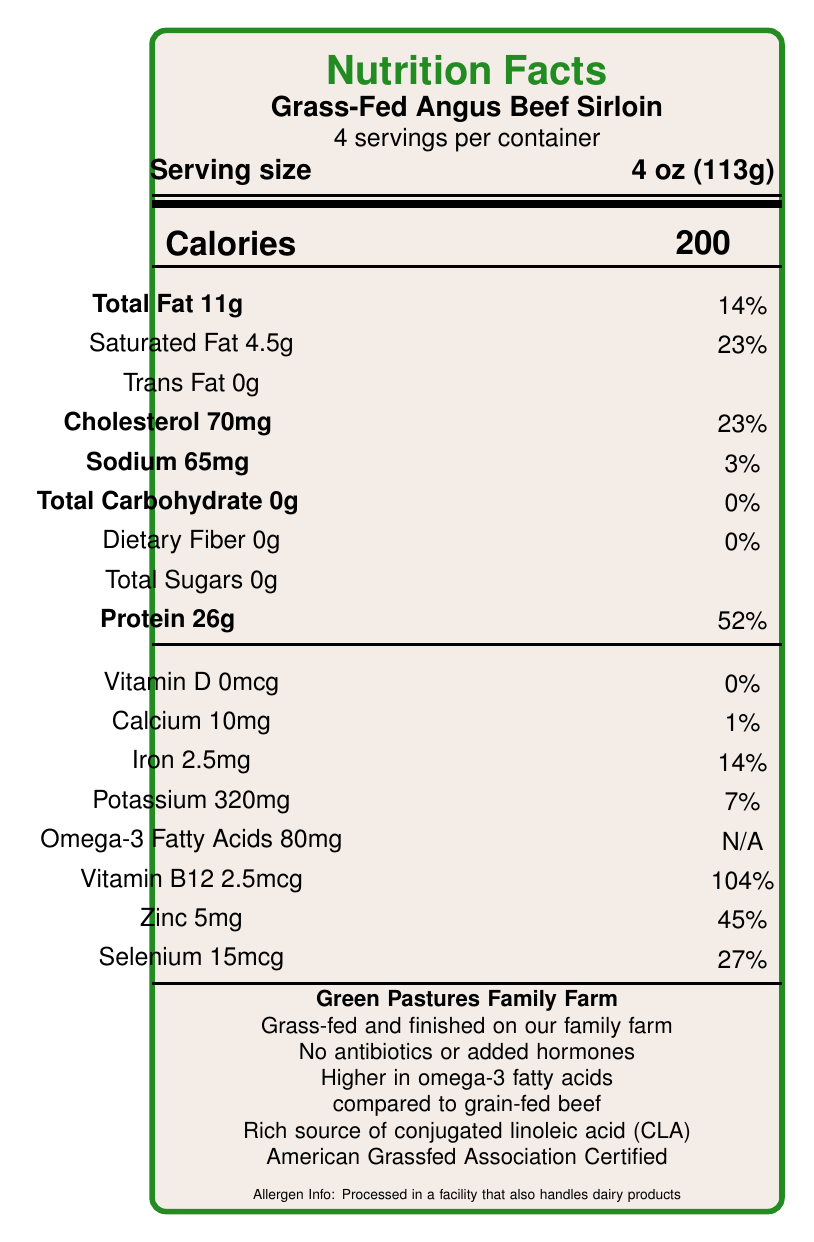what is the serving size? The serving size is explicitly listed on the document as "4 oz (113g)".
Answer: 4 oz (113g) how many servings are in the container? The document states there are 4 servings per container.
Answer: 4 how many calories are in one serving? The document specifies that each serving contains 200 calories.
Answer: 200 what is the total fat content in one serving? The document lists the total fat per serving as 11g.
Answer: 11g what percentage of the daily value of protein does one serving provide? The document states that one serving provides 52% of the daily value of protein.
Answer: 52% does this product contain any trans fat? The document lists trans fat content as 0g.
Answer: No what vitamins and minerals are prominently featured in this product? A. Vitamin C and Calcium B. Vitamin B12 and Zinc C. Iron and Vitamin A D. Vitamin D and Potassium The document highlights significant amounts of Vitamin B12 (104%) and Zinc (45%).
Answer: B which of the following describe a nutritional benefit of this product? A. High in carbohydrates B. Excellent source of calcium C. Rich in omega-3 fatty acids D. Low in cholesterol The document notes that the product is higher in omega-3 fatty acids compared to grain-fed beef.
Answer: C is this product certified by any organization? The document mentions that the product is "American Grassfed Association Certified".
Answer: Yes describe the main idea of the document. The document is a detailed Nutrition Facts label for Grass-Fed Angus Beef Sirloin, including both the nutritional content per serving and claims about its benefits and certifications.
Answer: The document provides the Nutrition Facts and additional information for Grass-Fed Angus Beef Sirloin, detailing its serving size, caloric content, fat, cholesterol, sodium, carbohydrate, protein, vitamins, and minerals. Additionally, it highlights the product's benefits, such as being raised without antibiotics or added hormones, and its higher omega-3 fatty acid content compared to grain-fed beef. how much potassium is in one serving? The document specifies that there are 320mg of potassium in one serving.
Answer: 320mg what is the farm name that produces this product? The bottom of the document states that the product is from "Green Pastures Family Farm".
Answer: Green Pastures Family Farm how much cholesterol is in one serving, and what percentage of the daily value does it represent? The document indicates that one serving contains 70mg of cholesterol, which is 23% of the daily value.
Answer: 70mg, 23% what is the total carbohydrate content per serving? The document notes that the total carbohydrate content per serving is 0g.
Answer: 0g how much iron does one serving provide, and what percentage of the daily value is it? The document lists that one serving contains 2.5mg of iron, which represents 14% of the daily value.
Answer: 2.5mg, 14% is this product safe for individuals with dairy allergies? The document states that it is processed in a facility that also handles dairy products, but it does not definitively state if the product itself contains dairy.
Answer: Cannot be determined 